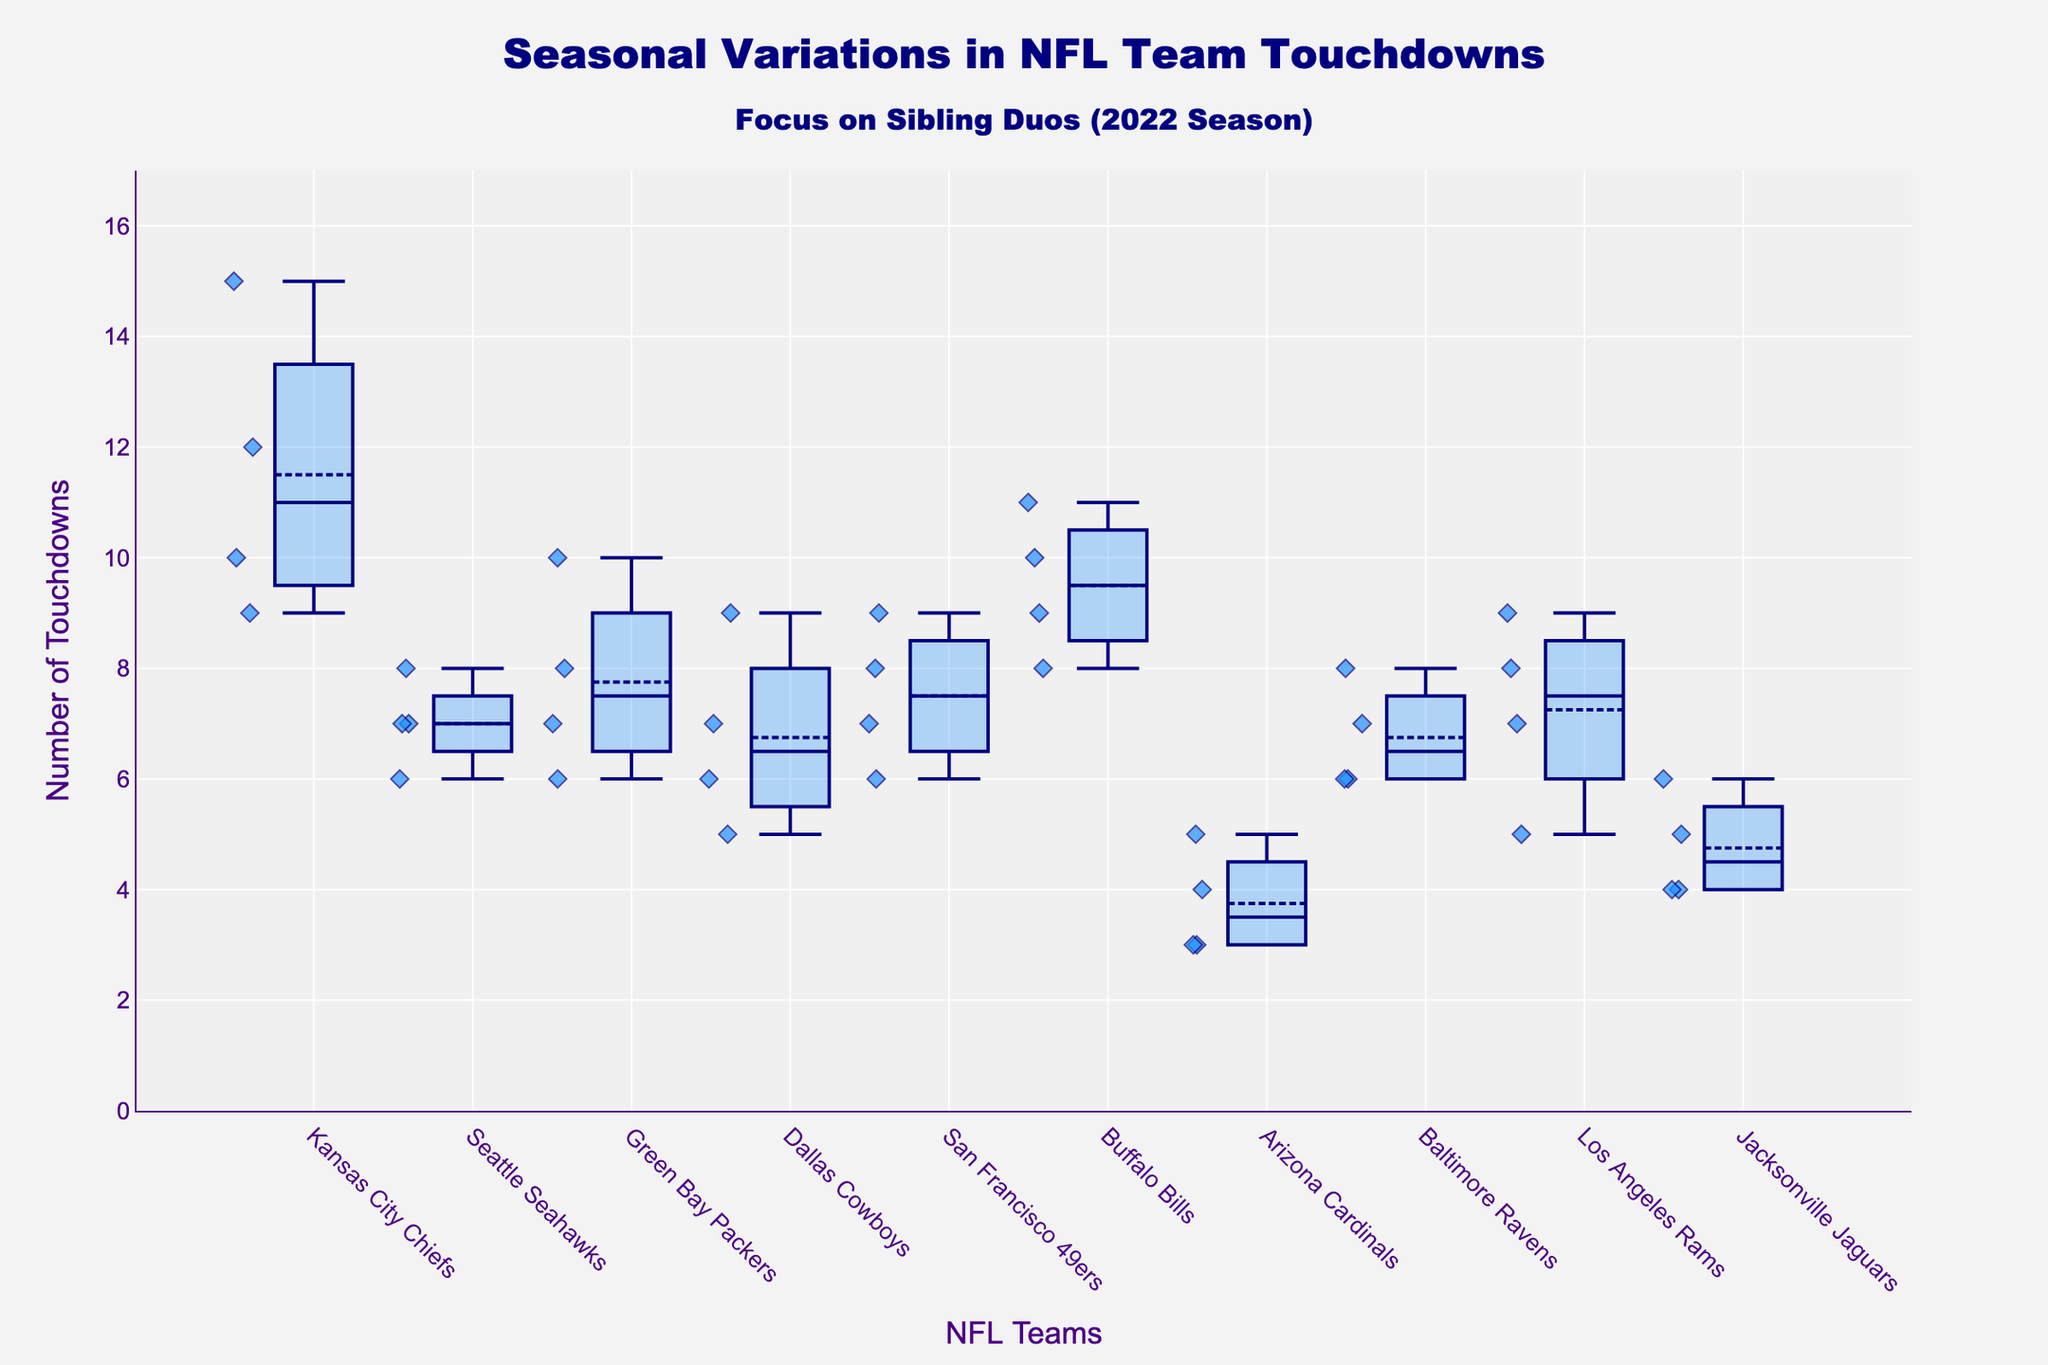What is the color of the box plot in the figure? The box plot color is a shade of blue, specifically a dark blue line, with the box filled partially in a light blue color.
Answer: Blue What is the title of the figure? The title of the figure is "Seasonal Variations in NFL Team Touchdowns" with a sub-title "Focus on Sibling Duos (2022 Season)."
Answer: Seasonal Variations in NFL Team Touchdowns Which team scored the highest number of touchdowns in a quarter? By examining the data points, the Kansas City Chiefs scored the highest number of touchdowns in a quarter, with 15 touchdowns in Q2.
Answer: Kansas City Chiefs What is the median number of touchdowns scored by the Dallas Cowboys? From the box plot, the median is depicted by the line inside the box. For the Dallas Cowboys, it appears to be around 6.5.
Answer: 6.5 Which team has the widest interquartile range (IQR) of touchdowns? The IQR is the range between Q1 and Q3. Kansas City Chiefs show the widest spread of data, indicating a larger IQR.
Answer: Kansas City Chiefs Which team has the lowest minimum value of touchdowns in any quarter? The minimum value is determined by the lowest whisker point on the plot. The Arizona Cardinals have the lowest minimum value, which is 3.
Answer: Arizona Cardinals Compare the median values of touchdowns between the Buffalo Bills and the Green Bay Packers. The median value is represented by the line inside each box plot. The Buffalo Bills have a higher median value compared to the Green Bay Packers.
Answer: Buffalo Bills What is the average number of touchdowns for the Cincinnati Bengals? Since the Cincinnati Bengals data isn't provided in the plot, we can conclude they are not included in this analysis.
Answer: Not included Identify the quarter with the most consistency in touchdown scores across all teams. Consistency can be identified by the shortest box lengths. Q1 and Q4 have relatively shorter box heights, indicating consistent touchdown scores.
Answer: Q1 and Q4 